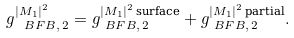Convert formula to latex. <formula><loc_0><loc_0><loc_500><loc_500>g _ { \ B F B , \, 2 } ^ { | M _ { 1 } | ^ { 2 } } & = g _ { \ B F B , \, 2 } ^ { | M _ { 1 } | ^ { 2 } \, \text {surface} } + g _ { \ B F B , \, 2 } ^ { | M _ { 1 } | ^ { 2 } \, \text {partial} } .</formula> 